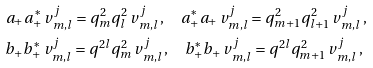Convert formula to latex. <formula><loc_0><loc_0><loc_500><loc_500>& a _ { + } a _ { + } ^ { * } \, v ^ { j } _ { m , l } = q _ { m } ^ { 2 } q _ { l } ^ { 2 } \, v ^ { j } _ { m , l } \, , \quad a _ { + } ^ { * } a _ { + } \, v ^ { j } _ { m , l } = q _ { m + 1 } ^ { 2 } q _ { l + 1 } ^ { 2 } \, v ^ { j } _ { m , l } \, , \\ & b _ { + } b _ { + } ^ { * } \, v ^ { j } _ { m , l } = q ^ { 2 l } q _ { m } ^ { 2 } \, v ^ { j } _ { m , l } \, , \quad b _ { + } ^ { * } b _ { + } \, v ^ { j } _ { m , l } = q ^ { 2 l } q _ { m + 1 } ^ { 2 } \, v ^ { j } _ { m , l } \, ,</formula> 